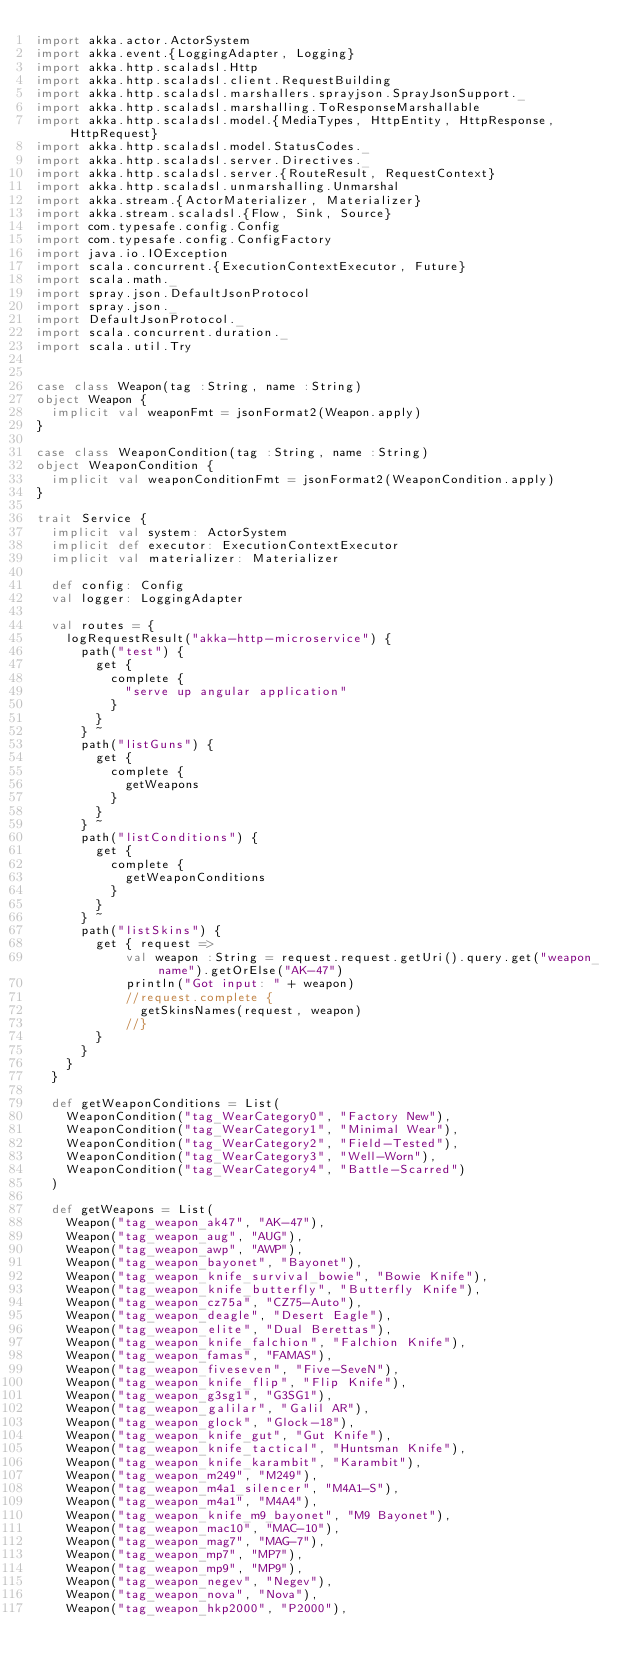<code> <loc_0><loc_0><loc_500><loc_500><_Scala_>import akka.actor.ActorSystem
import akka.event.{LoggingAdapter, Logging}
import akka.http.scaladsl.Http
import akka.http.scaladsl.client.RequestBuilding
import akka.http.scaladsl.marshallers.sprayjson.SprayJsonSupport._
import akka.http.scaladsl.marshalling.ToResponseMarshallable
import akka.http.scaladsl.model.{MediaTypes, HttpEntity, HttpResponse, HttpRequest}
import akka.http.scaladsl.model.StatusCodes._
import akka.http.scaladsl.server.Directives._
import akka.http.scaladsl.server.{RouteResult, RequestContext}
import akka.http.scaladsl.unmarshalling.Unmarshal
import akka.stream.{ActorMaterializer, Materializer}
import akka.stream.scaladsl.{Flow, Sink, Source}
import com.typesafe.config.Config
import com.typesafe.config.ConfigFactory
import java.io.IOException
import scala.concurrent.{ExecutionContextExecutor, Future}
import scala.math._
import spray.json.DefaultJsonProtocol
import spray.json._
import DefaultJsonProtocol._
import scala.concurrent.duration._
import scala.util.Try


case class Weapon(tag :String, name :String)
object Weapon {
  implicit val weaponFmt = jsonFormat2(Weapon.apply)
}

case class WeaponCondition(tag :String, name :String)
object WeaponCondition {
  implicit val weaponConditionFmt = jsonFormat2(WeaponCondition.apply)
}

trait Service {
  implicit val system: ActorSystem
  implicit def executor: ExecutionContextExecutor
  implicit val materializer: Materializer

  def config: Config
  val logger: LoggingAdapter

  val routes = {
    logRequestResult("akka-http-microservice") {
      path("test") {
        get {
          complete {
            "serve up angular application"
          }
        }
      } ~
      path("listGuns") {
        get {
          complete {
            getWeapons
          }
        }
      } ~
      path("listConditions") {
        get {
          complete {
            getWeaponConditions
          }
        }
      } ~
      path("listSkins") {
        get { request =>
            val weapon :String = request.request.getUri().query.get("weapon_name").getOrElse("AK-47")
            println("Got input: " + weapon)
            //request.complete {
              getSkinsNames(request, weapon)
            //}
        }
      }
    }
  }

  def getWeaponConditions = List(
    WeaponCondition("tag_WearCategory0", "Factory New"),
    WeaponCondition("tag_WearCategory1", "Minimal Wear"),
    WeaponCondition("tag_WearCategory2", "Field-Tested"),
    WeaponCondition("tag_WearCategory3", "Well-Worn"),
    WeaponCondition("tag_WearCategory4", "Battle-Scarred")
  )

  def getWeapons = List(
    Weapon("tag_weapon_ak47", "AK-47"),
    Weapon("tag_weapon_aug", "AUG"),
    Weapon("tag_weapon_awp", "AWP"),
    Weapon("tag_weapon_bayonet", "Bayonet"),
    Weapon("tag_weapon_knife_survival_bowie", "Bowie Knife"),
    Weapon("tag_weapon_knife_butterfly", "Butterfly Knife"),
    Weapon("tag_weapon_cz75a", "CZ75-Auto"),
    Weapon("tag_weapon_deagle", "Desert Eagle"),
    Weapon("tag_weapon_elite", "Dual Berettas"),
    Weapon("tag_weapon_knife_falchion", "Falchion Knife"),
    Weapon("tag_weapon_famas", "FAMAS"),
    Weapon("tag_weapon_fiveseven", "Five-SeveN"),
    Weapon("tag_weapon_knife_flip", "Flip Knife"),
    Weapon("tag_weapon_g3sg1", "G3SG1"),
    Weapon("tag_weapon_galilar", "Galil AR"),
    Weapon("tag_weapon_glock", "Glock-18"),
    Weapon("tag_weapon_knife_gut", "Gut Knife"),
    Weapon("tag_weapon_knife_tactical", "Huntsman Knife"),
    Weapon("tag_weapon_knife_karambit", "Karambit"),
    Weapon("tag_weapon_m249", "M249"),
    Weapon("tag_weapon_m4a1_silencer", "M4A1-S"),
    Weapon("tag_weapon_m4a1", "M4A4"),
    Weapon("tag_weapon_knife_m9_bayonet", "M9 Bayonet"),
    Weapon("tag_weapon_mac10", "MAC-10"),
    Weapon("tag_weapon_mag7", "MAG-7"),
    Weapon("tag_weapon_mp7", "MP7"),
    Weapon("tag_weapon_mp9", "MP9"),
    Weapon("tag_weapon_negev", "Negev"),
    Weapon("tag_weapon_nova", "Nova"),
    Weapon("tag_weapon_hkp2000", "P2000"),</code> 